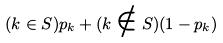Convert formula to latex. <formula><loc_0><loc_0><loc_500><loc_500>( k \in S ) p _ { k } + ( k \notin S ) ( 1 - p _ { k } )</formula> 